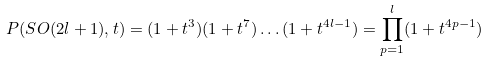Convert formula to latex. <formula><loc_0><loc_0><loc_500><loc_500>P ( S O ( 2 l + 1 ) , t ) = ( 1 + t ^ { 3 } ) ( 1 + t ^ { 7 } ) \dots ( 1 + t ^ { 4 l - 1 } ) = \prod ^ { l } _ { p = 1 } ( 1 + t ^ { 4 p - 1 } )</formula> 